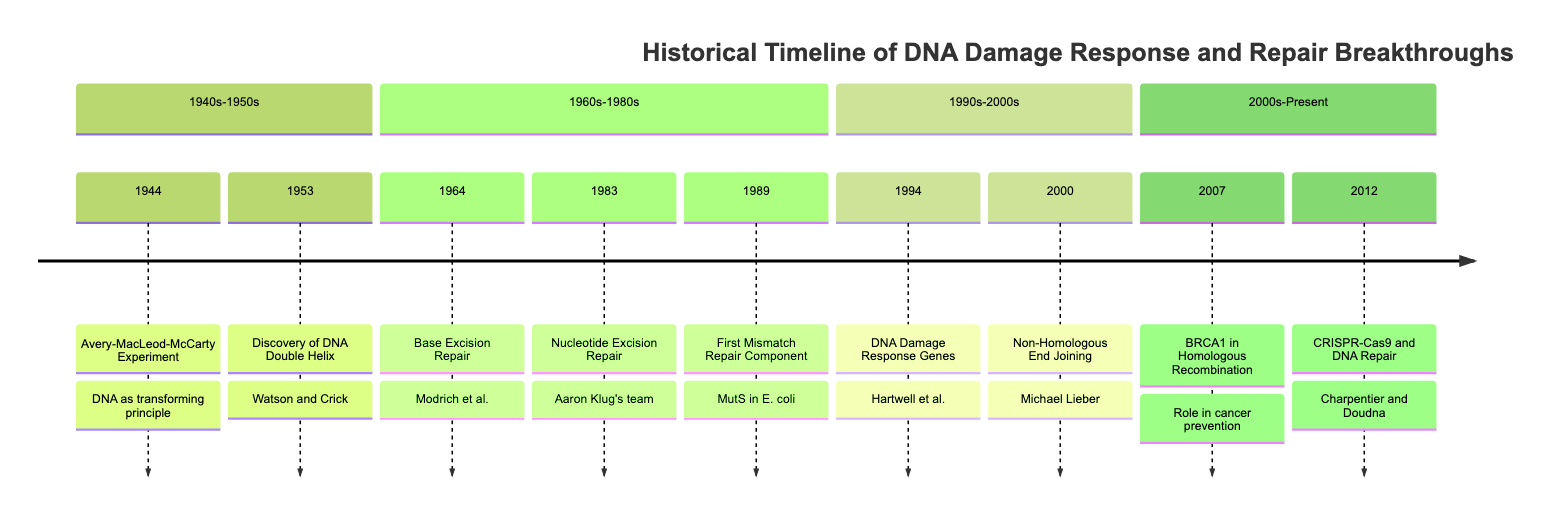What year did the Avery-MacLeod-McCarty Experiment occur? The diagram shows that the Avery-MacLeod-McCarty Experiment happened in 1944, as indicated in the timeline section for the 1940s-1950s.
Answer: 1944 Who proposed the DNA double helix structure? In the diagram, it is stated that James Watson and Francis Crick are the ones who proposed the double helix structure of DNA in 1953.
Answer: Watson and Crick What mechanism was identified in 1964? The timeline indicates that in 1964, base excision repair was identified. It shows the specific event linked to that year.
Answer: Base Excision Repair How many years apart were the discoveries of base excision repair and nucleotide excision repair? The timeline indicates that base excision repair was identified in 1964 and nucleotide excision repair in 1983. To find the difference, subtract 1964 from 1983, which equals 19 years.
Answer: 19 years Which DNA repair pathway was highlighted in 2007? According to the timeline, 2007 is noted for showing the role of BRCA1 in homologous recombination, which is a significant DNA repair pathway.
Answer: Homologous Recombination What significant technology was developed in 2012? The timeline states that CRISPR-Cas9 was developed in 2012, marking a significant advancement in genome editing and DNA repair studies.
Answer: CRISPR-Cas9 What discovery connects cell cycle regulation to DNA repair mechanisms? The timeline indicates that in 1994, the identification of DNA damage response genes in yeast connected cell cycle regulation to DNA repair mechanisms.
Answer: DNA Damage Response Genes Which event marks the earliest point in the timeline regarding DNA repair mechanisms? The earliest event listed in the timeline is the Avery-MacLeod-McCarty Experiment in 1944, which is the first occurrence in the timeline.
Answer: Avery-MacLeod-McCarty Experiment 